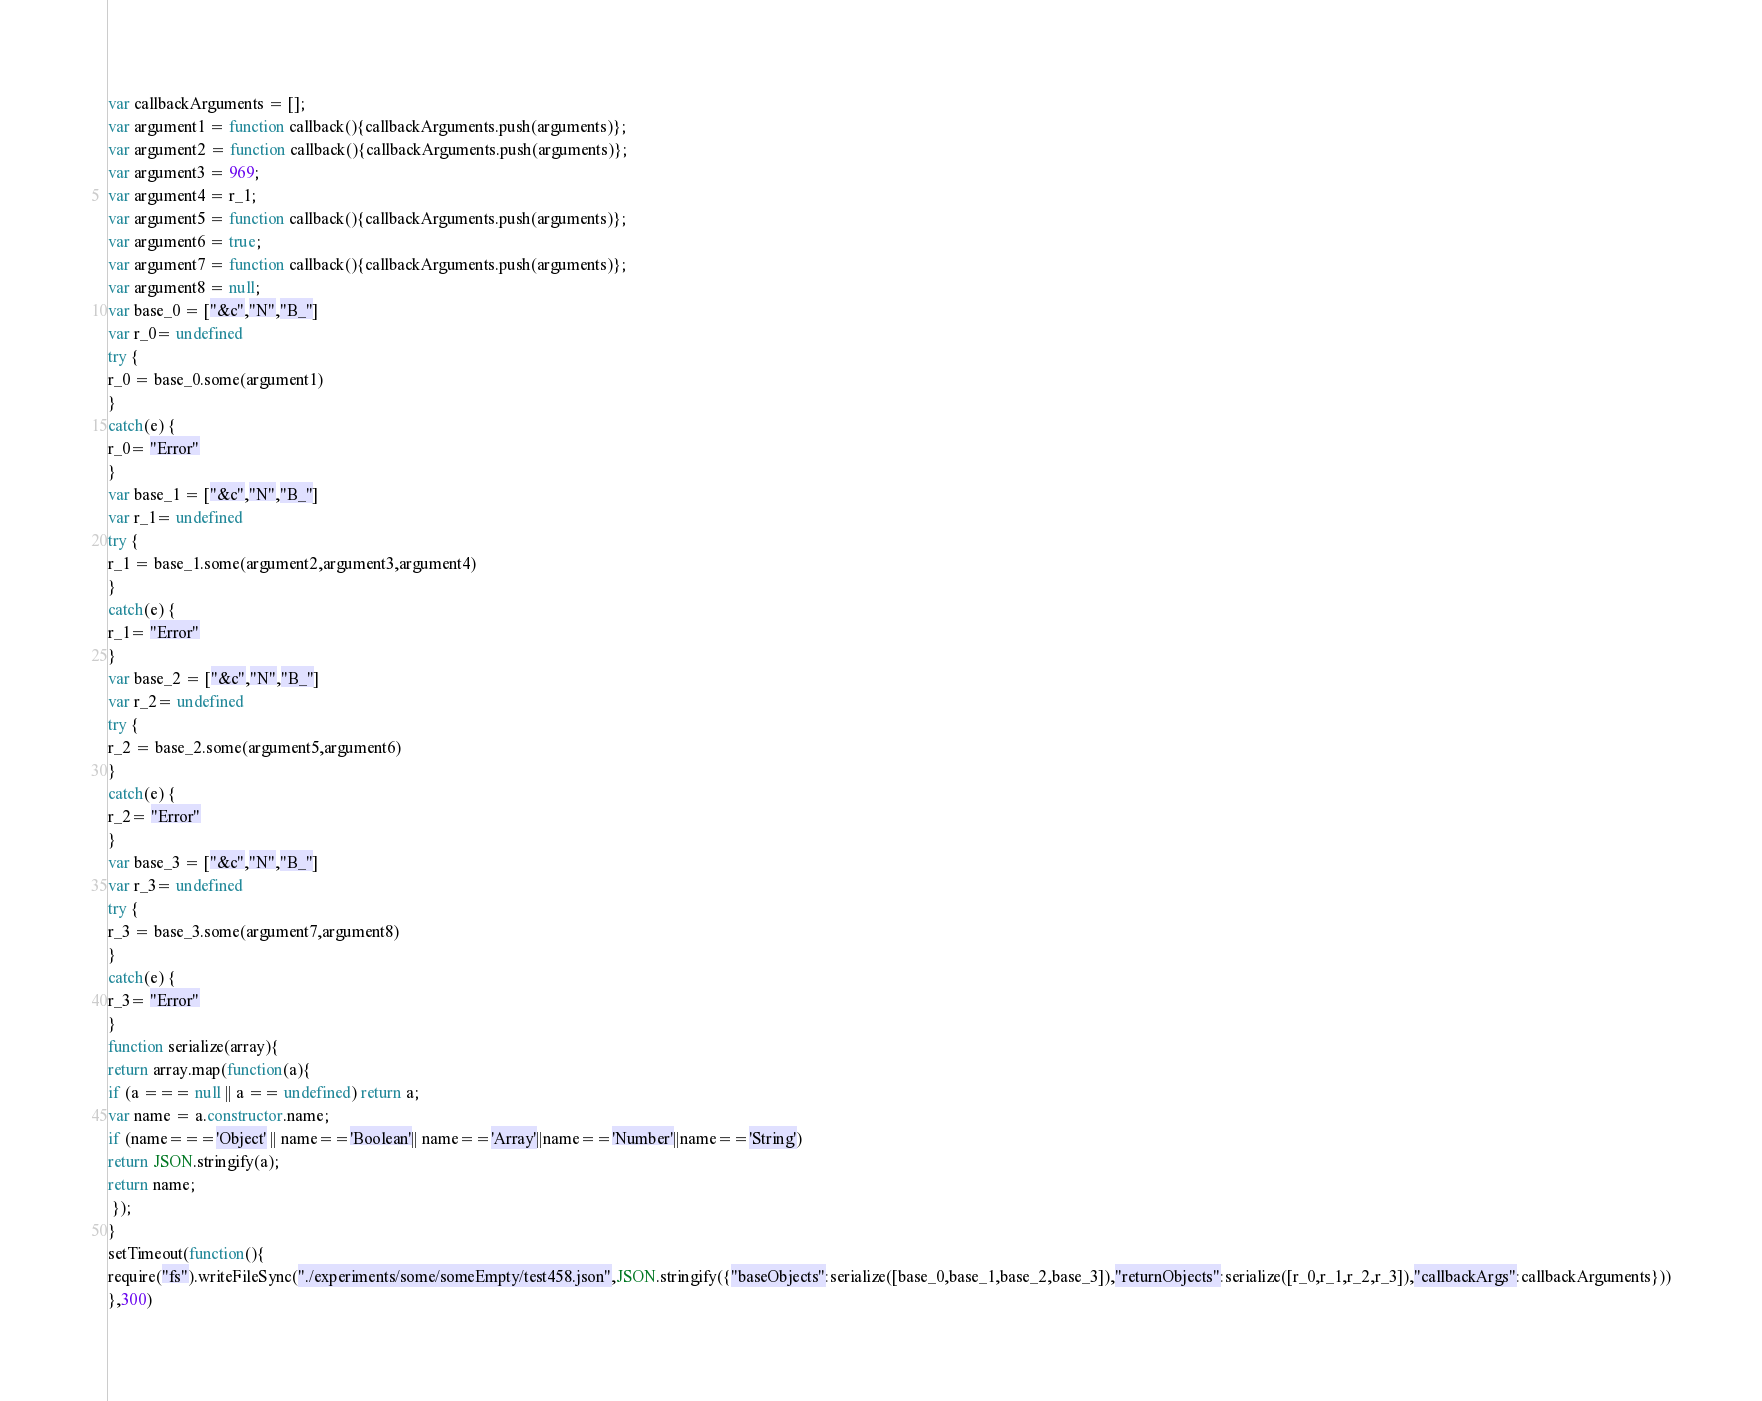Convert code to text. <code><loc_0><loc_0><loc_500><loc_500><_JavaScript_>



var callbackArguments = [];
var argument1 = function callback(){callbackArguments.push(arguments)};
var argument2 = function callback(){callbackArguments.push(arguments)};
var argument3 = 969;
var argument4 = r_1;
var argument5 = function callback(){callbackArguments.push(arguments)};
var argument6 = true;
var argument7 = function callback(){callbackArguments.push(arguments)};
var argument8 = null;
var base_0 = ["&c","N","B_"]
var r_0= undefined
try {
r_0 = base_0.some(argument1)
}
catch(e) {
r_0= "Error"
}
var base_1 = ["&c","N","B_"]
var r_1= undefined
try {
r_1 = base_1.some(argument2,argument3,argument4)
}
catch(e) {
r_1= "Error"
}
var base_2 = ["&c","N","B_"]
var r_2= undefined
try {
r_2 = base_2.some(argument5,argument6)
}
catch(e) {
r_2= "Error"
}
var base_3 = ["&c","N","B_"]
var r_3= undefined
try {
r_3 = base_3.some(argument7,argument8)
}
catch(e) {
r_3= "Error"
}
function serialize(array){
return array.map(function(a){
if (a === null || a == undefined) return a;
var name = a.constructor.name;
if (name==='Object' || name=='Boolean'|| name=='Array'||name=='Number'||name=='String')
return JSON.stringify(a);
return name;
 });
}
setTimeout(function(){
require("fs").writeFileSync("./experiments/some/someEmpty/test458.json",JSON.stringify({"baseObjects":serialize([base_0,base_1,base_2,base_3]),"returnObjects":serialize([r_0,r_1,r_2,r_3]),"callbackArgs":callbackArguments}))
},300)</code> 